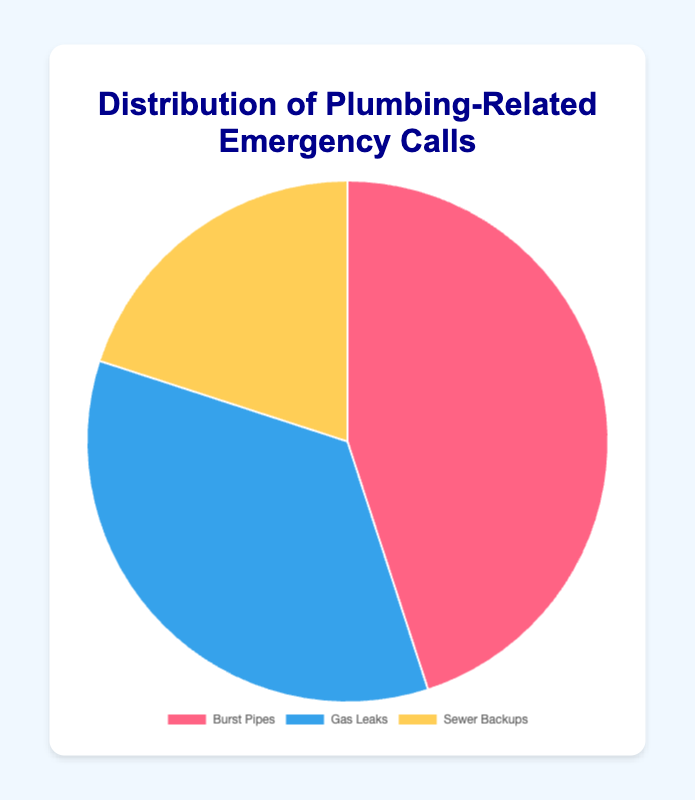What is the most common type of plumbing-related emergency call? The pie chart shows the percentages of each type of emergency call. The largest slice represents Burst Pipes at 45%, which is the highest percentage among the categories.
Answer: Burst Pipes Which issue accounts for the smallest percentage of emergency calls? By observing the pie chart, the smallest slice corresponds to Sewer Backups at 20%.
Answer: Sewer Backups How much more frequent are Burst Pipes emergencies compared to Gas Leaks? The percentage for Burst Pipes is 45% and for Gas Leaks is 35%. The difference is 45% - 35% = 10%.
Answer: 10% What percentage of the plumbing-related emergency calls are not related to Burst Pipes? The percentage for Burst Pipes is 45%. The remaining percentage is 100% - 45% = 55%.
Answer: 55% Do Gas Leaks and Sewer Backups together make up more or less than half of the emergency calls? Adding the percentages for Gas Leaks (35%) and Sewer Backups (20%) gives 35% + 20% = 55%, which is more than half.
Answer: More Which issue has a moderately sized slice in the chart? The pie chart shows that Gas Leaks have a slice larger than Sewer Backups but smaller than Burst Pipes, making it moderately sized at 35%.
Answer: Gas Leaks How does the visual representation of Burst Pipes compare to the other issues? The Burst Pipes slice is the largest and visually stands out due to its size, indicating it constitutes the highest percentage of emergency calls.
Answer: It is the largest If you combine the percentages of Burst Pipes and Sewer Backups, what is the total percentage? Summing the percentages for Burst Pipes (45%) and Sewer Backups (20%) results in 45% + 20% = 65%.
Answer: 65% How do the visual sizes of the slices for Gas Leaks and Sewer Backups compare? The Gas Leaks slice is visibly larger than the Sewer Backups slice, indicating a higher percentage of emergency calls for Gas Leaks.
Answer: Gas Leaks slice is larger What is the average percentage of emergency calls across all three issues? The sum of the percentages for all three issues is 45% + 35% + 20% = 100%. Dividing by the three categories gives an average of 100% / 3 ≈ 33.33%.
Answer: About 33.33% 